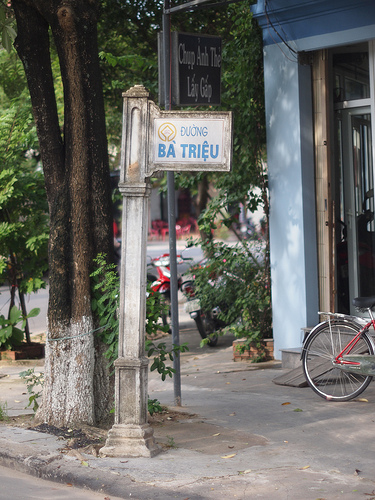What can you tell me about the setting of this image? This image appears to depict a street scene likely in an urban area. There's a sign showing 'DUONG BA TRIEU.' Nearby, there is some greenery and a bicycle partially visible in the frame. The setting is composed of both natural elements and man-made structures, creating a vibrant street-side atmosphere. Can you describe an element in the image that shows human presence or activity? The presence of the bicycle leaning against the sidewalk indicates human activity. It suggests that people use this area for cycling and perhaps run errands or visit nearby shops and homes. 